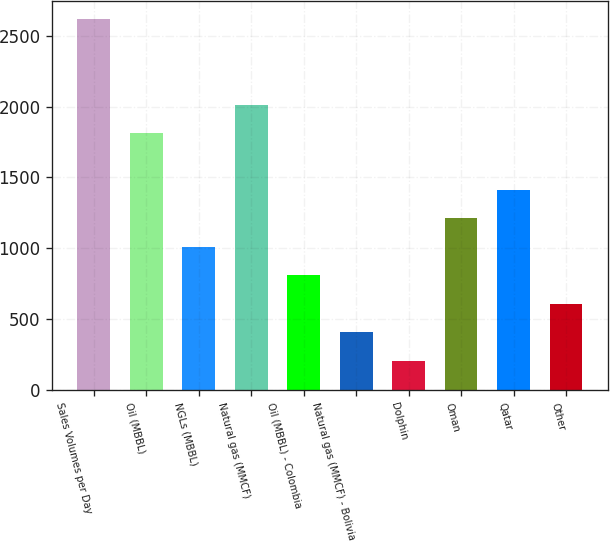Convert chart to OTSL. <chart><loc_0><loc_0><loc_500><loc_500><bar_chart><fcel>Sales Volumes per Day<fcel>Oil (MBBL)<fcel>NGLs (MBBL)<fcel>Natural gas (MMCF)<fcel>Oil (MBBL) - Colombia<fcel>Natural gas (MMCF) - Bolivia<fcel>Dolphin<fcel>Oman<fcel>Qatar<fcel>Other<nl><fcel>2616.4<fcel>1813.2<fcel>1010<fcel>2014<fcel>809.2<fcel>407.6<fcel>206.8<fcel>1210.8<fcel>1411.6<fcel>608.4<nl></chart> 